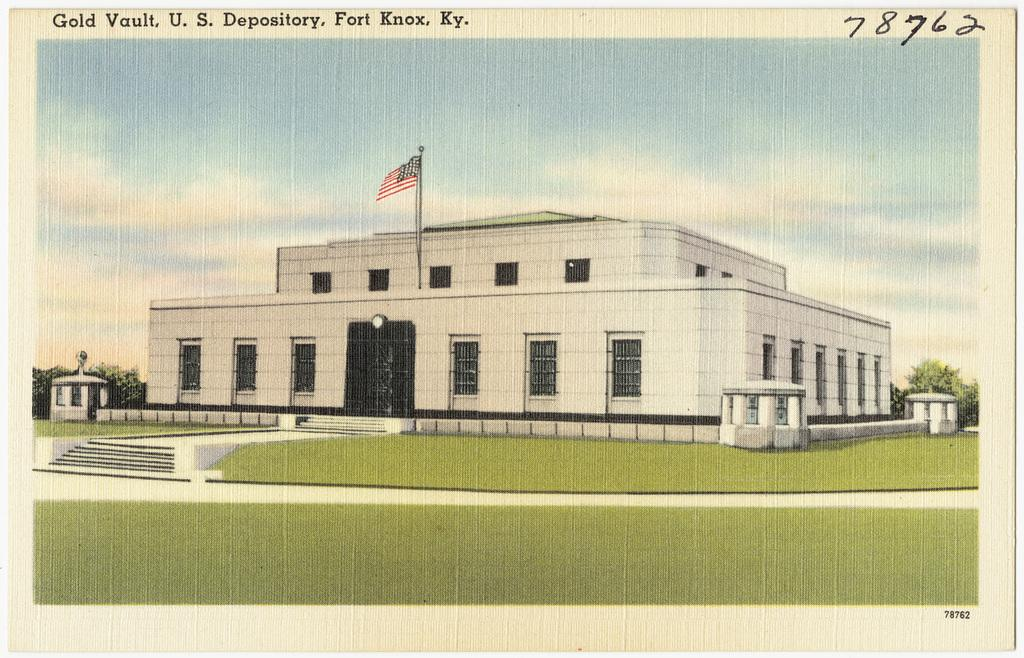What is there is a poster of a building in the image, what does the building have? The building has doors and windows. What can be seen in the background of the image? There are trees and a clear sky in the background of the image. Can you see a stamp on the building's door in the image? There is no stamp visible on the building's door in the image. 